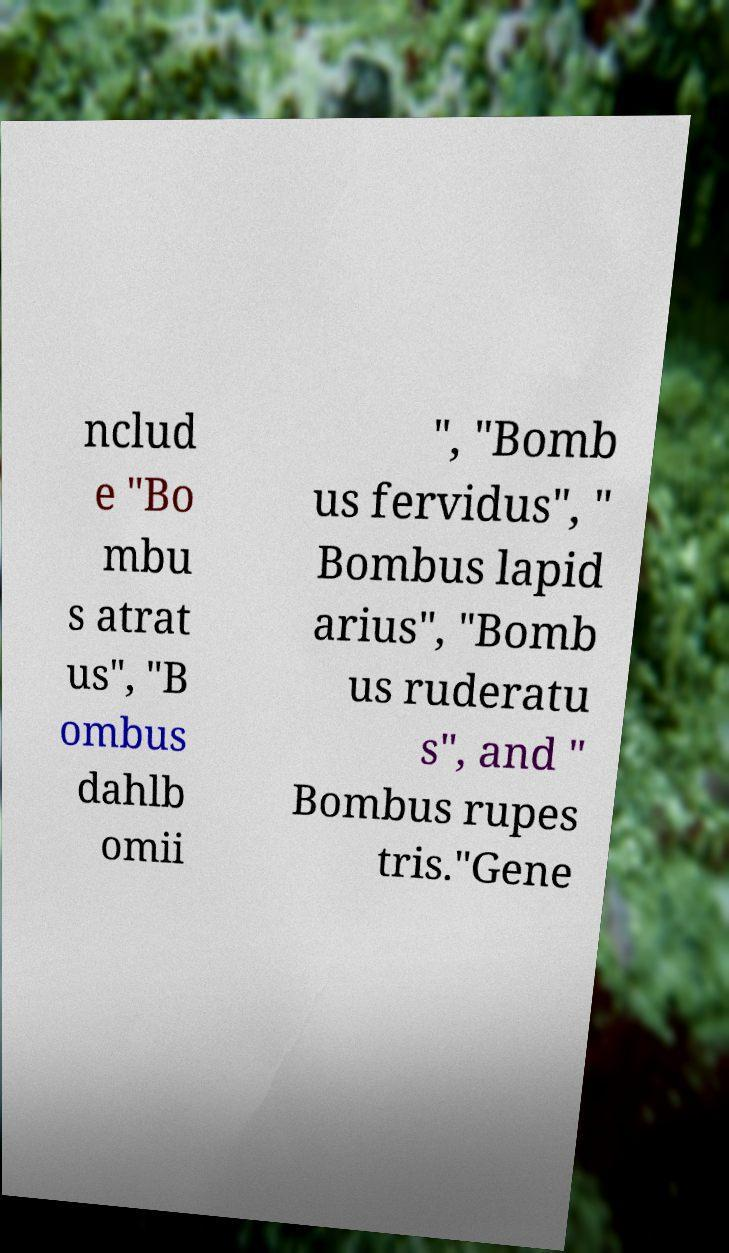Can you read and provide the text displayed in the image?This photo seems to have some interesting text. Can you extract and type it out for me? nclud e "Bo mbu s atrat us", "B ombus dahlb omii ", "Bomb us fervidus", " Bombus lapid arius", "Bomb us ruderatu s", and " Bombus rupes tris."Gene 